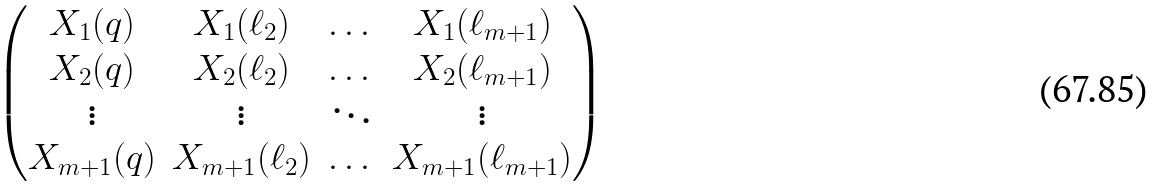<formula> <loc_0><loc_0><loc_500><loc_500>\begin{pmatrix} X _ { 1 } ( q ) & X _ { 1 } ( \ell _ { 2 } ) & \dots & X _ { 1 } ( \ell _ { m + 1 } ) \\ X _ { 2 } ( q ) & X _ { 2 } ( \ell _ { 2 } ) & \dots & X _ { 2 } ( \ell _ { m + 1 } ) \\ \vdots & \vdots & \ddots & \vdots \\ X _ { m + 1 } ( q ) & X _ { m + 1 } ( \ell _ { 2 } ) & \dots & X _ { m + 1 } ( \ell _ { m + 1 } ) \end{pmatrix}</formula> 